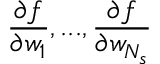Convert formula to latex. <formula><loc_0><loc_0><loc_500><loc_500>\frac { \partial f } { \partial w _ { 1 } } , \dots , \frac { \partial f } { \partial w _ { N _ { s } } }</formula> 